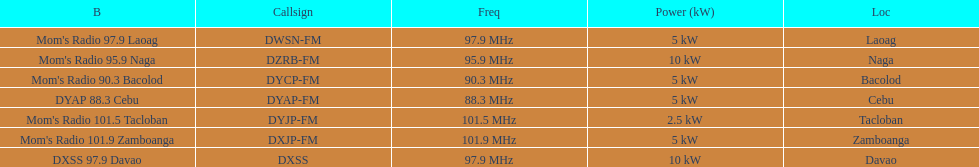How many stations have at least 5 kw or more listed in the power column? 6. Could you parse the entire table as a dict? {'header': ['B', 'Callsign', 'Freq', 'Power (kW)', 'Loc'], 'rows': [["Mom's Radio 97.9 Laoag", 'DWSN-FM', '97.9\xa0MHz', '5\xa0kW', 'Laoag'], ["Mom's Radio 95.9 Naga", 'DZRB-FM', '95.9\xa0MHz', '10\xa0kW', 'Naga'], ["Mom's Radio 90.3 Bacolod", 'DYCP-FM', '90.3\xa0MHz', '5\xa0kW', 'Bacolod'], ['DYAP 88.3 Cebu', 'DYAP-FM', '88.3\xa0MHz', '5\xa0kW', 'Cebu'], ["Mom's Radio 101.5 Tacloban", 'DYJP-FM', '101.5\xa0MHz', '2.5\xa0kW', 'Tacloban'], ["Mom's Radio 101.9 Zamboanga", 'DXJP-FM', '101.9\xa0MHz', '5\xa0kW', 'Zamboanga'], ['DXSS 97.9 Davao', 'DXSS', '97.9\xa0MHz', '10\xa0kW', 'Davao']]} 